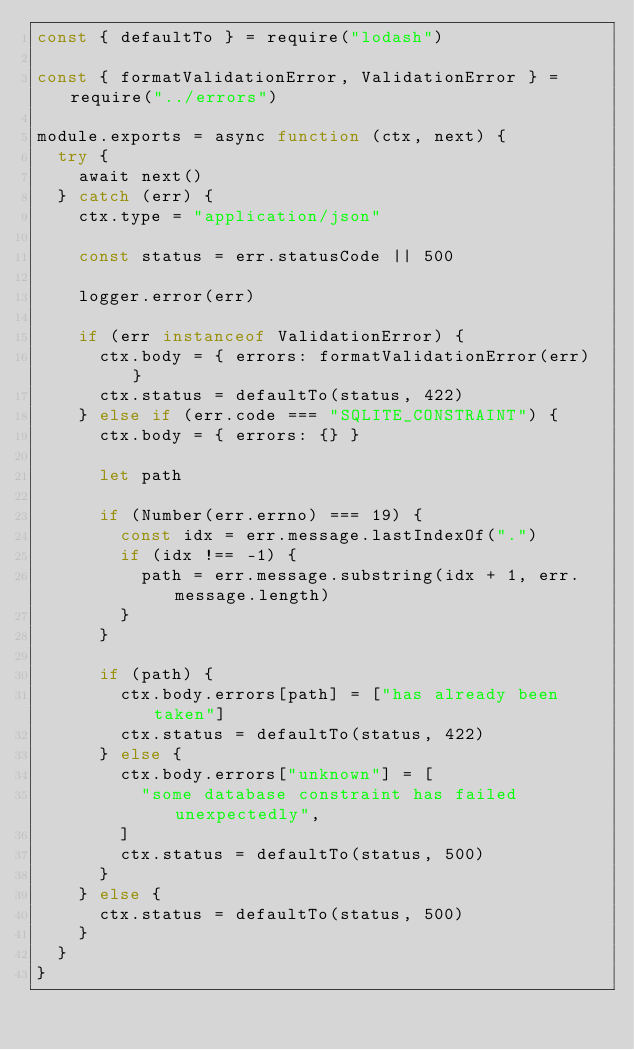<code> <loc_0><loc_0><loc_500><loc_500><_JavaScript_>const { defaultTo } = require("lodash")

const { formatValidationError, ValidationError } = require("../errors")

module.exports = async function (ctx, next) {
  try {
    await next()
  } catch (err) {
    ctx.type = "application/json"

    const status = err.statusCode || 500

    logger.error(err)

    if (err instanceof ValidationError) {
      ctx.body = { errors: formatValidationError(err) }
      ctx.status = defaultTo(status, 422)
    } else if (err.code === "SQLITE_CONSTRAINT") {
      ctx.body = { errors: {} }

      let path

      if (Number(err.errno) === 19) {
        const idx = err.message.lastIndexOf(".")
        if (idx !== -1) {
          path = err.message.substring(idx + 1, err.message.length)
        }
      }

      if (path) {
        ctx.body.errors[path] = ["has already been taken"]
        ctx.status = defaultTo(status, 422)
      } else {
        ctx.body.errors["unknown"] = [
          "some database constraint has failed unexpectedly",
        ]
        ctx.status = defaultTo(status, 500)
      }
    } else {
      ctx.status = defaultTo(status, 500)
    }
  }
}
</code> 